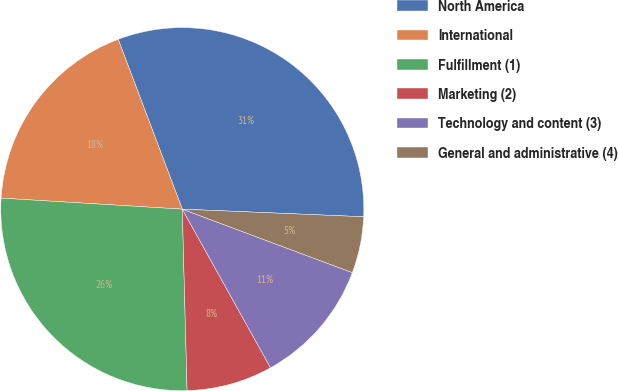Convert chart. <chart><loc_0><loc_0><loc_500><loc_500><pie_chart><fcel>North America<fcel>International<fcel>Fulfillment (1)<fcel>Marketing (2)<fcel>Technology and content (3)<fcel>General and administrative (4)<nl><fcel>31.41%<fcel>18.29%<fcel>26.39%<fcel>7.66%<fcel>11.23%<fcel>5.02%<nl></chart> 